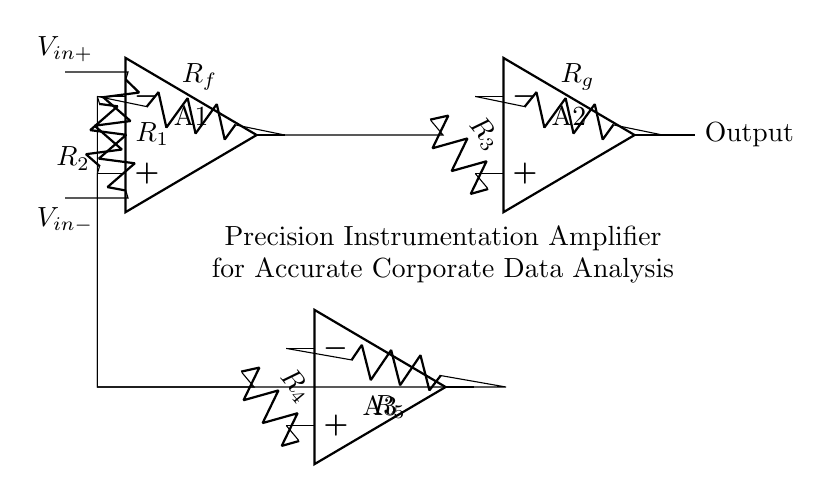What are the components used in this circuit? The circuit includes three operational amplifiers, resistors labeled R1, R2, Rf, Rg, R3, R4, and R5.
Answer: operational amplifiers, R1, R2, Rf, Rg, R3, R4, R5 What is the role of the feedback resistor Rf? Rf is part of the feedback loop for the first operational amplifier, which helps control the gain of the amplifier and stabilize the output.
Answer: control the gain Which operational amplifier has the output labeled? The output is labeled on the second operational amplifier, which processes the signals from the first one.
Answer: second operational amplifier How many resistors are in the circuit? There are six resistors in the circuit, named R1, R2, Rf, Rg, R3, R4, and R5.
Answer: six What are the input voltages for this amplifier? The input voltages are V_in+ and V_in-, which are connected to the non-inverting and inverting terminals of the first operational amplifier, respectively.
Answer: V_in+, V_in- What is the configuration of the operational amplifiers in this circuit? The configuration shows the use of a precision instrumentation amplifier setup, where each op-amp serves a specific role in amplifying differential signals accurately.
Answer: precision instrumentation amplifier What purpose does the final output serve in data analysis? The final output provides the amplified voltage signal, which allows for accurate data analysis necessary for informed corporate decision-making.
Answer: accurate data analysis 